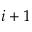<formula> <loc_0><loc_0><loc_500><loc_500>i + 1</formula> 